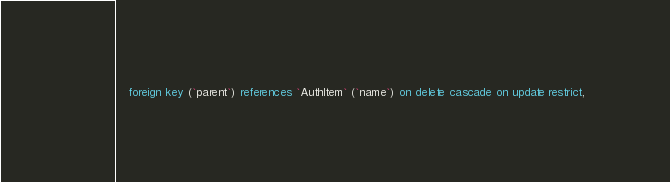Convert code to text. <code><loc_0><loc_0><loc_500><loc_500><_SQL_>   foreign key (`parent`) references `AuthItem` (`name`) on delete cascade on update restrict,</code> 